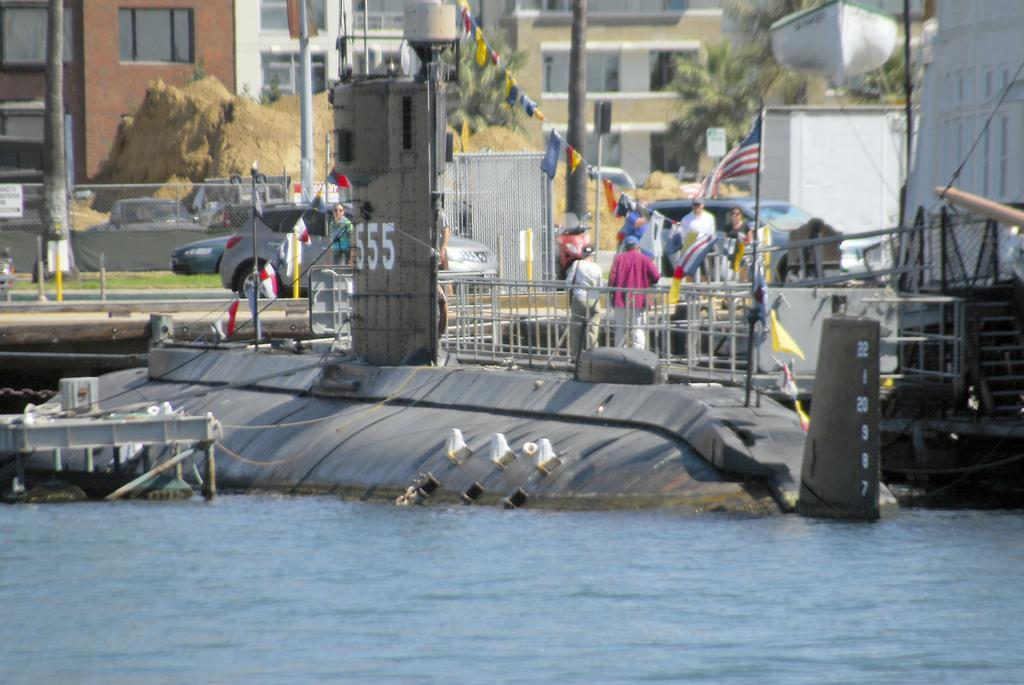In one or two sentences, can you explain what this image depicts? In this image we can see buildings, hills, trees, grills, persons standing on the ground, motor vehicles and flags tied to the ropes. 